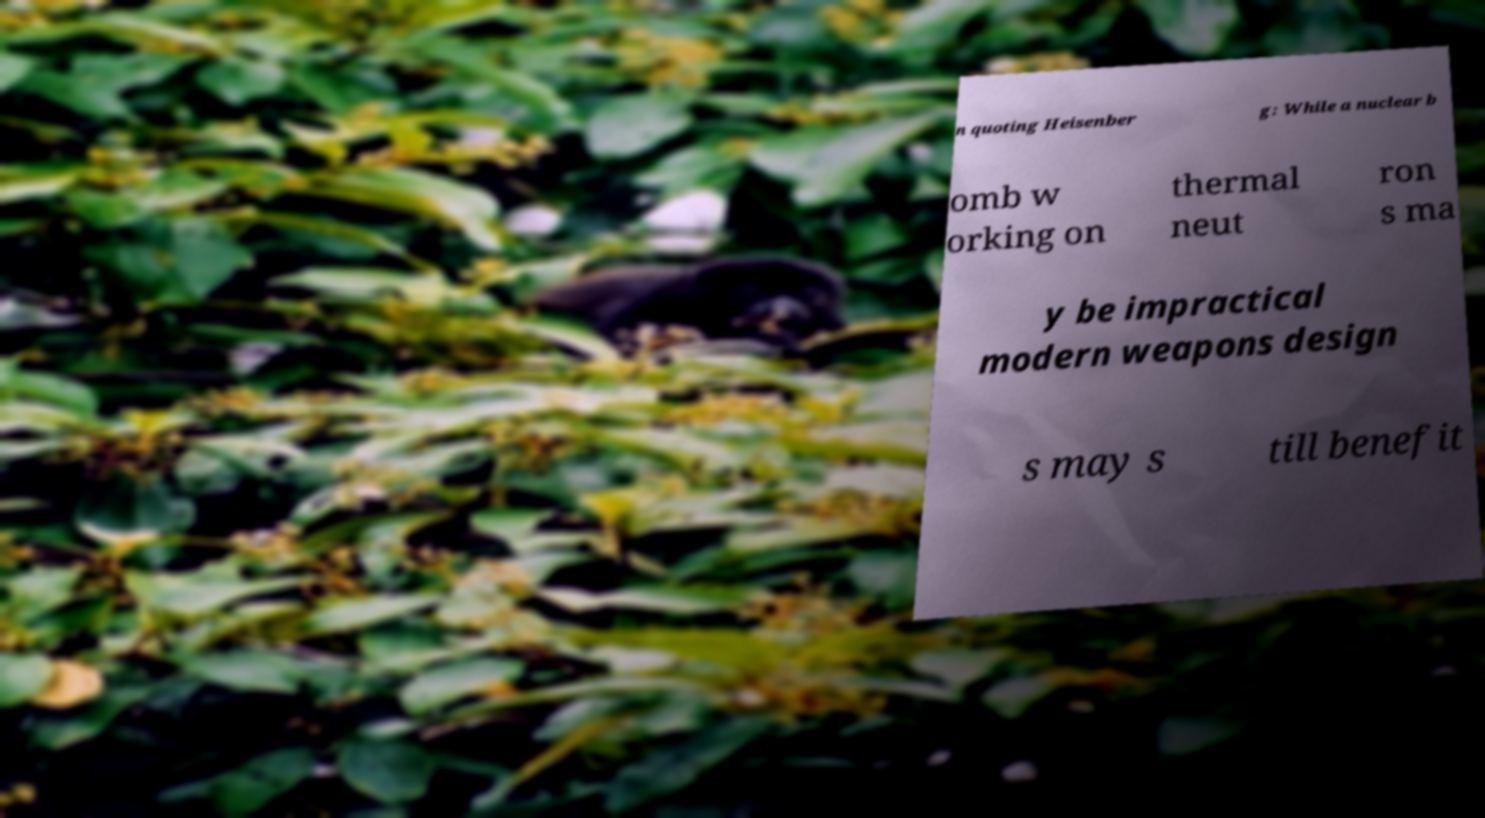Could you extract and type out the text from this image? n quoting Heisenber g: While a nuclear b omb w orking on thermal neut ron s ma y be impractical modern weapons design s may s till benefit 